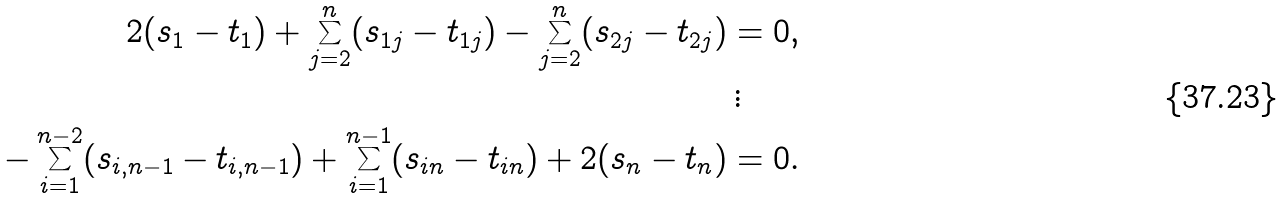<formula> <loc_0><loc_0><loc_500><loc_500>2 ( s _ { 1 } - t _ { 1 } ) + \sum _ { j = 2 } ^ { n } ( s _ { 1 j } - t _ { 1 j } ) - \sum _ { j = 2 } ^ { n } ( s _ { 2 j } - t _ { 2 j } ) & = 0 , \\ & \, \vdots \\ - \sum _ { i = 1 } ^ { n - 2 } ( s _ { i , n - 1 } - t _ { i , n - 1 } ) + \sum _ { i = 1 } ^ { n - 1 } ( s _ { i n } - t _ { i n } ) + 2 ( s _ { n } - t _ { n } ) & = 0 .</formula> 